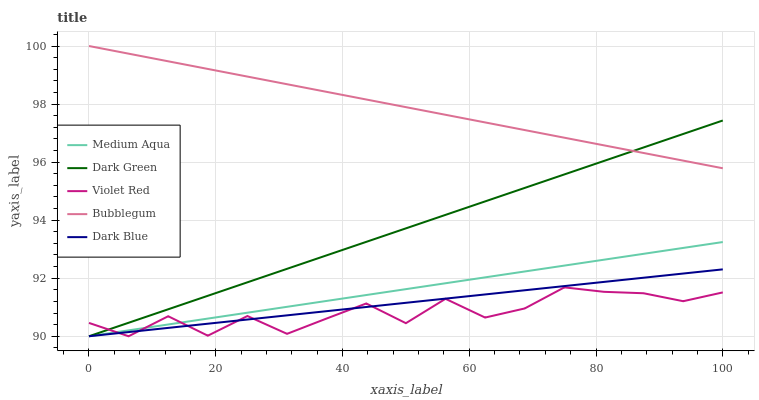Does Violet Red have the minimum area under the curve?
Answer yes or no. Yes. Does Bubblegum have the maximum area under the curve?
Answer yes or no. Yes. Does Medium Aqua have the minimum area under the curve?
Answer yes or no. No. Does Medium Aqua have the maximum area under the curve?
Answer yes or no. No. Is Bubblegum the smoothest?
Answer yes or no. Yes. Is Violet Red the roughest?
Answer yes or no. Yes. Is Medium Aqua the smoothest?
Answer yes or no. No. Is Medium Aqua the roughest?
Answer yes or no. No. Does Dark Blue have the lowest value?
Answer yes or no. Yes. Does Bubblegum have the lowest value?
Answer yes or no. No. Does Bubblegum have the highest value?
Answer yes or no. Yes. Does Medium Aqua have the highest value?
Answer yes or no. No. Is Violet Red less than Bubblegum?
Answer yes or no. Yes. Is Bubblegum greater than Violet Red?
Answer yes or no. Yes. Does Dark Green intersect Medium Aqua?
Answer yes or no. Yes. Is Dark Green less than Medium Aqua?
Answer yes or no. No. Is Dark Green greater than Medium Aqua?
Answer yes or no. No. Does Violet Red intersect Bubblegum?
Answer yes or no. No. 